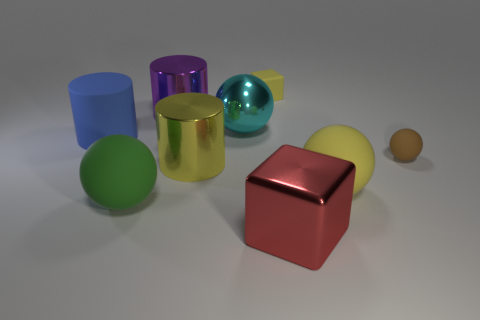What material is the large ball that is the same color as the small matte block?
Your answer should be compact. Rubber. Is the green object the same size as the yellow rubber cube?
Your answer should be very brief. No. Are there more brown things than shiny things?
Offer a terse response. No. How many other objects are the same color as the small cube?
Make the answer very short. 2. How many things are yellow blocks or tiny brown matte cylinders?
Your answer should be very brief. 1. There is a small object in front of the tiny yellow object; is its shape the same as the large cyan thing?
Keep it short and to the point. Yes. The large matte object that is behind the small rubber thing in front of the small yellow cube is what color?
Provide a short and direct response. Blue. Are there fewer big cyan spheres than tiny cyan matte spheres?
Make the answer very short. No. Is there a small blue sphere that has the same material as the yellow cube?
Your answer should be very brief. No. Do the tiny brown thing and the yellow rubber object that is in front of the purple object have the same shape?
Provide a succinct answer. Yes. 